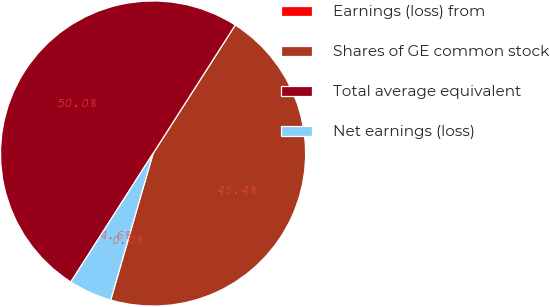<chart> <loc_0><loc_0><loc_500><loc_500><pie_chart><fcel>Earnings (loss) from<fcel>Shares of GE common stock<fcel>Total average equivalent<fcel>Net earnings (loss)<nl><fcel>0.0%<fcel>45.42%<fcel>50.0%<fcel>4.58%<nl></chart> 